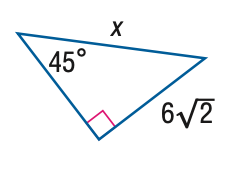Question: Find x.
Choices:
A. 6
B. 4 \sqrt { 6 }
C. 12
D. 12 \sqrt { 2 }
Answer with the letter. Answer: C 